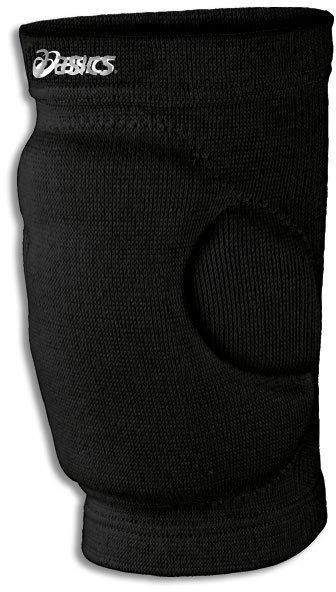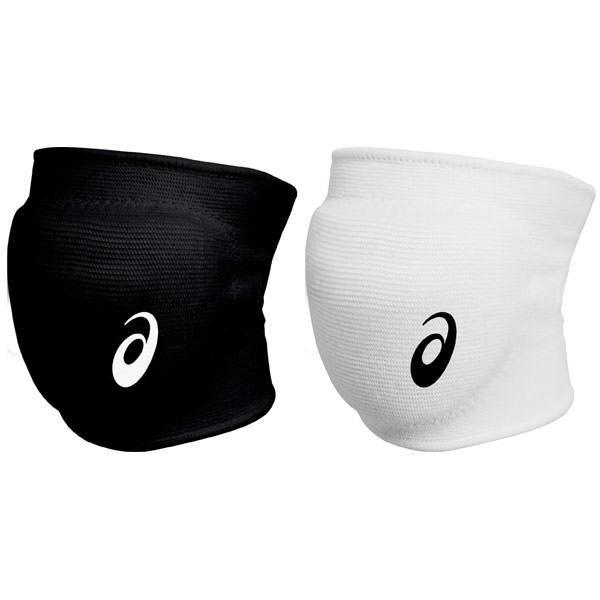The first image is the image on the left, the second image is the image on the right. Given the left and right images, does the statement "There are three or fewer black knee pads." hold true? Answer yes or no. Yes. The first image is the image on the left, the second image is the image on the right. For the images displayed, is the sentence "There is at least one white protective pad." factually correct? Answer yes or no. Yes. 